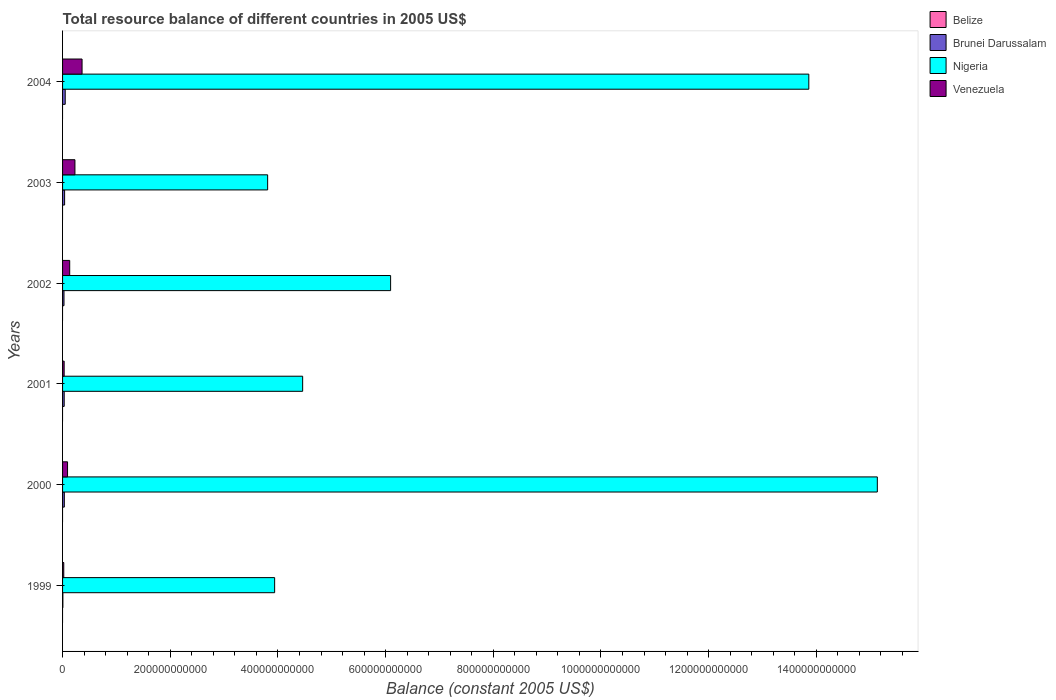How many different coloured bars are there?
Give a very brief answer. 3. How many groups of bars are there?
Offer a very short reply. 6. Are the number of bars per tick equal to the number of legend labels?
Your response must be concise. No. Are the number of bars on each tick of the Y-axis equal?
Offer a terse response. Yes. What is the label of the 3rd group of bars from the top?
Your answer should be compact. 2002. In how many cases, is the number of bars for a given year not equal to the number of legend labels?
Offer a very short reply. 6. What is the total resource balance in Venezuela in 2002?
Your answer should be very brief. 1.33e+1. Across all years, what is the maximum total resource balance in Venezuela?
Provide a short and direct response. 3.62e+1. Across all years, what is the minimum total resource balance in Nigeria?
Keep it short and to the point. 3.81e+11. What is the total total resource balance in Venezuela in the graph?
Your answer should be compact. 8.69e+1. What is the difference between the total resource balance in Nigeria in 2000 and that in 2003?
Your answer should be compact. 1.13e+12. What is the difference between the total resource balance in Brunei Darussalam in 2001 and the total resource balance in Nigeria in 2003?
Provide a short and direct response. -3.78e+11. What is the average total resource balance in Nigeria per year?
Ensure brevity in your answer.  7.88e+11. In the year 1999, what is the difference between the total resource balance in Nigeria and total resource balance in Venezuela?
Your answer should be compact. 3.92e+11. What is the ratio of the total resource balance in Venezuela in 2002 to that in 2003?
Your answer should be compact. 0.58. Is the total resource balance in Nigeria in 2000 less than that in 2001?
Your response must be concise. No. What is the difference between the highest and the second highest total resource balance in Brunei Darussalam?
Provide a succinct answer. 1.12e+09. What is the difference between the highest and the lowest total resource balance in Brunei Darussalam?
Give a very brief answer. 4.35e+09. In how many years, is the total resource balance in Venezuela greater than the average total resource balance in Venezuela taken over all years?
Offer a very short reply. 2. Is it the case that in every year, the sum of the total resource balance in Belize and total resource balance in Brunei Darussalam is greater than the sum of total resource balance in Nigeria and total resource balance in Venezuela?
Give a very brief answer. No. Are all the bars in the graph horizontal?
Provide a short and direct response. Yes. What is the difference between two consecutive major ticks on the X-axis?
Your answer should be very brief. 2.00e+11. Does the graph contain grids?
Your response must be concise. No. How are the legend labels stacked?
Provide a short and direct response. Vertical. What is the title of the graph?
Keep it short and to the point. Total resource balance of different countries in 2005 US$. What is the label or title of the X-axis?
Make the answer very short. Balance (constant 2005 US$). What is the label or title of the Y-axis?
Offer a terse response. Years. What is the Balance (constant 2005 US$) in Brunei Darussalam in 1999?
Provide a succinct answer. 5.78e+08. What is the Balance (constant 2005 US$) in Nigeria in 1999?
Your answer should be very brief. 3.94e+11. What is the Balance (constant 2005 US$) in Venezuela in 1999?
Your answer should be very brief. 2.23e+09. What is the Balance (constant 2005 US$) in Belize in 2000?
Provide a short and direct response. 0. What is the Balance (constant 2005 US$) of Brunei Darussalam in 2000?
Your answer should be compact. 3.26e+09. What is the Balance (constant 2005 US$) in Nigeria in 2000?
Your answer should be compact. 1.51e+12. What is the Balance (constant 2005 US$) in Venezuela in 2000?
Offer a terse response. 9.26e+09. What is the Balance (constant 2005 US$) of Belize in 2001?
Keep it short and to the point. 0. What is the Balance (constant 2005 US$) in Brunei Darussalam in 2001?
Offer a very short reply. 3.04e+09. What is the Balance (constant 2005 US$) of Nigeria in 2001?
Provide a succinct answer. 4.46e+11. What is the Balance (constant 2005 US$) in Venezuela in 2001?
Provide a short and direct response. 2.96e+09. What is the Balance (constant 2005 US$) of Belize in 2002?
Ensure brevity in your answer.  0. What is the Balance (constant 2005 US$) in Brunei Darussalam in 2002?
Provide a short and direct response. 2.67e+09. What is the Balance (constant 2005 US$) in Nigeria in 2002?
Provide a short and direct response. 6.09e+11. What is the Balance (constant 2005 US$) in Venezuela in 2002?
Offer a terse response. 1.33e+1. What is the Balance (constant 2005 US$) of Brunei Darussalam in 2003?
Give a very brief answer. 3.81e+09. What is the Balance (constant 2005 US$) of Nigeria in 2003?
Offer a very short reply. 3.81e+11. What is the Balance (constant 2005 US$) in Venezuela in 2003?
Provide a succinct answer. 2.30e+1. What is the Balance (constant 2005 US$) in Brunei Darussalam in 2004?
Provide a succinct answer. 4.92e+09. What is the Balance (constant 2005 US$) in Nigeria in 2004?
Make the answer very short. 1.39e+12. What is the Balance (constant 2005 US$) in Venezuela in 2004?
Offer a terse response. 3.62e+1. Across all years, what is the maximum Balance (constant 2005 US$) of Brunei Darussalam?
Make the answer very short. 4.92e+09. Across all years, what is the maximum Balance (constant 2005 US$) in Nigeria?
Your answer should be compact. 1.51e+12. Across all years, what is the maximum Balance (constant 2005 US$) in Venezuela?
Provide a succinct answer. 3.62e+1. Across all years, what is the minimum Balance (constant 2005 US$) of Brunei Darussalam?
Offer a terse response. 5.78e+08. Across all years, what is the minimum Balance (constant 2005 US$) of Nigeria?
Keep it short and to the point. 3.81e+11. Across all years, what is the minimum Balance (constant 2005 US$) in Venezuela?
Make the answer very short. 2.23e+09. What is the total Balance (constant 2005 US$) in Brunei Darussalam in the graph?
Provide a succinct answer. 1.83e+1. What is the total Balance (constant 2005 US$) in Nigeria in the graph?
Ensure brevity in your answer.  4.73e+12. What is the total Balance (constant 2005 US$) in Venezuela in the graph?
Your response must be concise. 8.69e+1. What is the difference between the Balance (constant 2005 US$) of Brunei Darussalam in 1999 and that in 2000?
Your answer should be very brief. -2.68e+09. What is the difference between the Balance (constant 2005 US$) of Nigeria in 1999 and that in 2000?
Provide a succinct answer. -1.12e+12. What is the difference between the Balance (constant 2005 US$) in Venezuela in 1999 and that in 2000?
Provide a succinct answer. -7.04e+09. What is the difference between the Balance (constant 2005 US$) in Brunei Darussalam in 1999 and that in 2001?
Your answer should be compact. -2.47e+09. What is the difference between the Balance (constant 2005 US$) of Nigeria in 1999 and that in 2001?
Ensure brevity in your answer.  -5.20e+1. What is the difference between the Balance (constant 2005 US$) of Venezuela in 1999 and that in 2001?
Your response must be concise. -7.35e+08. What is the difference between the Balance (constant 2005 US$) in Brunei Darussalam in 1999 and that in 2002?
Your answer should be compact. -2.09e+09. What is the difference between the Balance (constant 2005 US$) of Nigeria in 1999 and that in 2002?
Give a very brief answer. -2.15e+11. What is the difference between the Balance (constant 2005 US$) of Venezuela in 1999 and that in 2002?
Your answer should be compact. -1.10e+1. What is the difference between the Balance (constant 2005 US$) in Brunei Darussalam in 1999 and that in 2003?
Offer a very short reply. -3.23e+09. What is the difference between the Balance (constant 2005 US$) in Nigeria in 1999 and that in 2003?
Make the answer very short. 1.30e+1. What is the difference between the Balance (constant 2005 US$) of Venezuela in 1999 and that in 2003?
Your response must be concise. -2.08e+1. What is the difference between the Balance (constant 2005 US$) of Brunei Darussalam in 1999 and that in 2004?
Provide a short and direct response. -4.35e+09. What is the difference between the Balance (constant 2005 US$) in Nigeria in 1999 and that in 2004?
Ensure brevity in your answer.  -9.92e+11. What is the difference between the Balance (constant 2005 US$) in Venezuela in 1999 and that in 2004?
Make the answer very short. -3.40e+1. What is the difference between the Balance (constant 2005 US$) of Brunei Darussalam in 2000 and that in 2001?
Your response must be concise. 2.19e+08. What is the difference between the Balance (constant 2005 US$) in Nigeria in 2000 and that in 2001?
Keep it short and to the point. 1.07e+12. What is the difference between the Balance (constant 2005 US$) in Venezuela in 2000 and that in 2001?
Give a very brief answer. 6.30e+09. What is the difference between the Balance (constant 2005 US$) in Brunei Darussalam in 2000 and that in 2002?
Your answer should be very brief. 5.95e+08. What is the difference between the Balance (constant 2005 US$) in Nigeria in 2000 and that in 2002?
Offer a very short reply. 9.04e+11. What is the difference between the Balance (constant 2005 US$) in Venezuela in 2000 and that in 2002?
Ensure brevity in your answer.  -3.99e+09. What is the difference between the Balance (constant 2005 US$) in Brunei Darussalam in 2000 and that in 2003?
Provide a succinct answer. -5.44e+08. What is the difference between the Balance (constant 2005 US$) in Nigeria in 2000 and that in 2003?
Provide a short and direct response. 1.13e+12. What is the difference between the Balance (constant 2005 US$) in Venezuela in 2000 and that in 2003?
Make the answer very short. -1.37e+1. What is the difference between the Balance (constant 2005 US$) of Brunei Darussalam in 2000 and that in 2004?
Provide a succinct answer. -1.66e+09. What is the difference between the Balance (constant 2005 US$) of Nigeria in 2000 and that in 2004?
Keep it short and to the point. 1.27e+11. What is the difference between the Balance (constant 2005 US$) of Venezuela in 2000 and that in 2004?
Your answer should be compact. -2.70e+1. What is the difference between the Balance (constant 2005 US$) of Brunei Darussalam in 2001 and that in 2002?
Keep it short and to the point. 3.76e+08. What is the difference between the Balance (constant 2005 US$) in Nigeria in 2001 and that in 2002?
Your answer should be very brief. -1.63e+11. What is the difference between the Balance (constant 2005 US$) of Venezuela in 2001 and that in 2002?
Ensure brevity in your answer.  -1.03e+1. What is the difference between the Balance (constant 2005 US$) of Brunei Darussalam in 2001 and that in 2003?
Provide a short and direct response. -7.63e+08. What is the difference between the Balance (constant 2005 US$) of Nigeria in 2001 and that in 2003?
Your response must be concise. 6.50e+1. What is the difference between the Balance (constant 2005 US$) in Venezuela in 2001 and that in 2003?
Provide a succinct answer. -2.00e+1. What is the difference between the Balance (constant 2005 US$) of Brunei Darussalam in 2001 and that in 2004?
Keep it short and to the point. -1.88e+09. What is the difference between the Balance (constant 2005 US$) of Nigeria in 2001 and that in 2004?
Make the answer very short. -9.40e+11. What is the difference between the Balance (constant 2005 US$) in Venezuela in 2001 and that in 2004?
Offer a terse response. -3.33e+1. What is the difference between the Balance (constant 2005 US$) in Brunei Darussalam in 2002 and that in 2003?
Offer a very short reply. -1.14e+09. What is the difference between the Balance (constant 2005 US$) of Nigeria in 2002 and that in 2003?
Make the answer very short. 2.28e+11. What is the difference between the Balance (constant 2005 US$) of Venezuela in 2002 and that in 2003?
Provide a succinct answer. -9.74e+09. What is the difference between the Balance (constant 2005 US$) in Brunei Darussalam in 2002 and that in 2004?
Keep it short and to the point. -2.26e+09. What is the difference between the Balance (constant 2005 US$) of Nigeria in 2002 and that in 2004?
Your answer should be compact. -7.77e+11. What is the difference between the Balance (constant 2005 US$) in Venezuela in 2002 and that in 2004?
Offer a terse response. -2.30e+1. What is the difference between the Balance (constant 2005 US$) of Brunei Darussalam in 2003 and that in 2004?
Make the answer very short. -1.12e+09. What is the difference between the Balance (constant 2005 US$) of Nigeria in 2003 and that in 2004?
Ensure brevity in your answer.  -1.01e+12. What is the difference between the Balance (constant 2005 US$) of Venezuela in 2003 and that in 2004?
Your answer should be very brief. -1.32e+1. What is the difference between the Balance (constant 2005 US$) in Brunei Darussalam in 1999 and the Balance (constant 2005 US$) in Nigeria in 2000?
Give a very brief answer. -1.51e+12. What is the difference between the Balance (constant 2005 US$) in Brunei Darussalam in 1999 and the Balance (constant 2005 US$) in Venezuela in 2000?
Offer a terse response. -8.69e+09. What is the difference between the Balance (constant 2005 US$) in Nigeria in 1999 and the Balance (constant 2005 US$) in Venezuela in 2000?
Ensure brevity in your answer.  3.85e+11. What is the difference between the Balance (constant 2005 US$) in Brunei Darussalam in 1999 and the Balance (constant 2005 US$) in Nigeria in 2001?
Offer a terse response. -4.45e+11. What is the difference between the Balance (constant 2005 US$) in Brunei Darussalam in 1999 and the Balance (constant 2005 US$) in Venezuela in 2001?
Offer a terse response. -2.38e+09. What is the difference between the Balance (constant 2005 US$) in Nigeria in 1999 and the Balance (constant 2005 US$) in Venezuela in 2001?
Your response must be concise. 3.91e+11. What is the difference between the Balance (constant 2005 US$) in Brunei Darussalam in 1999 and the Balance (constant 2005 US$) in Nigeria in 2002?
Give a very brief answer. -6.09e+11. What is the difference between the Balance (constant 2005 US$) in Brunei Darussalam in 1999 and the Balance (constant 2005 US$) in Venezuela in 2002?
Keep it short and to the point. -1.27e+1. What is the difference between the Balance (constant 2005 US$) of Nigeria in 1999 and the Balance (constant 2005 US$) of Venezuela in 2002?
Offer a terse response. 3.81e+11. What is the difference between the Balance (constant 2005 US$) of Brunei Darussalam in 1999 and the Balance (constant 2005 US$) of Nigeria in 2003?
Your answer should be compact. -3.80e+11. What is the difference between the Balance (constant 2005 US$) in Brunei Darussalam in 1999 and the Balance (constant 2005 US$) in Venezuela in 2003?
Keep it short and to the point. -2.24e+1. What is the difference between the Balance (constant 2005 US$) in Nigeria in 1999 and the Balance (constant 2005 US$) in Venezuela in 2003?
Make the answer very short. 3.71e+11. What is the difference between the Balance (constant 2005 US$) in Brunei Darussalam in 1999 and the Balance (constant 2005 US$) in Nigeria in 2004?
Give a very brief answer. -1.39e+12. What is the difference between the Balance (constant 2005 US$) of Brunei Darussalam in 1999 and the Balance (constant 2005 US$) of Venezuela in 2004?
Ensure brevity in your answer.  -3.56e+1. What is the difference between the Balance (constant 2005 US$) in Nigeria in 1999 and the Balance (constant 2005 US$) in Venezuela in 2004?
Your answer should be very brief. 3.58e+11. What is the difference between the Balance (constant 2005 US$) of Brunei Darussalam in 2000 and the Balance (constant 2005 US$) of Nigeria in 2001?
Provide a succinct answer. -4.43e+11. What is the difference between the Balance (constant 2005 US$) in Brunei Darussalam in 2000 and the Balance (constant 2005 US$) in Venezuela in 2001?
Offer a terse response. 3.01e+08. What is the difference between the Balance (constant 2005 US$) in Nigeria in 2000 and the Balance (constant 2005 US$) in Venezuela in 2001?
Your response must be concise. 1.51e+12. What is the difference between the Balance (constant 2005 US$) in Brunei Darussalam in 2000 and the Balance (constant 2005 US$) in Nigeria in 2002?
Provide a succinct answer. -6.06e+11. What is the difference between the Balance (constant 2005 US$) of Brunei Darussalam in 2000 and the Balance (constant 2005 US$) of Venezuela in 2002?
Offer a terse response. -9.99e+09. What is the difference between the Balance (constant 2005 US$) in Nigeria in 2000 and the Balance (constant 2005 US$) in Venezuela in 2002?
Ensure brevity in your answer.  1.50e+12. What is the difference between the Balance (constant 2005 US$) of Brunei Darussalam in 2000 and the Balance (constant 2005 US$) of Nigeria in 2003?
Keep it short and to the point. -3.78e+11. What is the difference between the Balance (constant 2005 US$) in Brunei Darussalam in 2000 and the Balance (constant 2005 US$) in Venezuela in 2003?
Ensure brevity in your answer.  -1.97e+1. What is the difference between the Balance (constant 2005 US$) of Nigeria in 2000 and the Balance (constant 2005 US$) of Venezuela in 2003?
Provide a short and direct response. 1.49e+12. What is the difference between the Balance (constant 2005 US$) of Brunei Darussalam in 2000 and the Balance (constant 2005 US$) of Nigeria in 2004?
Provide a short and direct response. -1.38e+12. What is the difference between the Balance (constant 2005 US$) of Brunei Darussalam in 2000 and the Balance (constant 2005 US$) of Venezuela in 2004?
Your response must be concise. -3.30e+1. What is the difference between the Balance (constant 2005 US$) in Nigeria in 2000 and the Balance (constant 2005 US$) in Venezuela in 2004?
Provide a short and direct response. 1.48e+12. What is the difference between the Balance (constant 2005 US$) in Brunei Darussalam in 2001 and the Balance (constant 2005 US$) in Nigeria in 2002?
Offer a very short reply. -6.06e+11. What is the difference between the Balance (constant 2005 US$) in Brunei Darussalam in 2001 and the Balance (constant 2005 US$) in Venezuela in 2002?
Offer a very short reply. -1.02e+1. What is the difference between the Balance (constant 2005 US$) in Nigeria in 2001 and the Balance (constant 2005 US$) in Venezuela in 2002?
Provide a succinct answer. 4.33e+11. What is the difference between the Balance (constant 2005 US$) of Brunei Darussalam in 2001 and the Balance (constant 2005 US$) of Nigeria in 2003?
Provide a short and direct response. -3.78e+11. What is the difference between the Balance (constant 2005 US$) in Brunei Darussalam in 2001 and the Balance (constant 2005 US$) in Venezuela in 2003?
Make the answer very short. -1.99e+1. What is the difference between the Balance (constant 2005 US$) of Nigeria in 2001 and the Balance (constant 2005 US$) of Venezuela in 2003?
Ensure brevity in your answer.  4.23e+11. What is the difference between the Balance (constant 2005 US$) in Brunei Darussalam in 2001 and the Balance (constant 2005 US$) in Nigeria in 2004?
Your answer should be compact. -1.38e+12. What is the difference between the Balance (constant 2005 US$) of Brunei Darussalam in 2001 and the Balance (constant 2005 US$) of Venezuela in 2004?
Ensure brevity in your answer.  -3.32e+1. What is the difference between the Balance (constant 2005 US$) in Nigeria in 2001 and the Balance (constant 2005 US$) in Venezuela in 2004?
Your answer should be compact. 4.10e+11. What is the difference between the Balance (constant 2005 US$) of Brunei Darussalam in 2002 and the Balance (constant 2005 US$) of Nigeria in 2003?
Give a very brief answer. -3.78e+11. What is the difference between the Balance (constant 2005 US$) of Brunei Darussalam in 2002 and the Balance (constant 2005 US$) of Venezuela in 2003?
Your response must be concise. -2.03e+1. What is the difference between the Balance (constant 2005 US$) of Nigeria in 2002 and the Balance (constant 2005 US$) of Venezuela in 2003?
Offer a terse response. 5.86e+11. What is the difference between the Balance (constant 2005 US$) in Brunei Darussalam in 2002 and the Balance (constant 2005 US$) in Nigeria in 2004?
Offer a terse response. -1.38e+12. What is the difference between the Balance (constant 2005 US$) of Brunei Darussalam in 2002 and the Balance (constant 2005 US$) of Venezuela in 2004?
Your response must be concise. -3.36e+1. What is the difference between the Balance (constant 2005 US$) of Nigeria in 2002 and the Balance (constant 2005 US$) of Venezuela in 2004?
Your answer should be compact. 5.73e+11. What is the difference between the Balance (constant 2005 US$) in Brunei Darussalam in 2003 and the Balance (constant 2005 US$) in Nigeria in 2004?
Offer a very short reply. -1.38e+12. What is the difference between the Balance (constant 2005 US$) of Brunei Darussalam in 2003 and the Balance (constant 2005 US$) of Venezuela in 2004?
Provide a short and direct response. -3.24e+1. What is the difference between the Balance (constant 2005 US$) of Nigeria in 2003 and the Balance (constant 2005 US$) of Venezuela in 2004?
Ensure brevity in your answer.  3.45e+11. What is the average Balance (constant 2005 US$) in Brunei Darussalam per year?
Your answer should be very brief. 3.05e+09. What is the average Balance (constant 2005 US$) of Nigeria per year?
Your answer should be very brief. 7.88e+11. What is the average Balance (constant 2005 US$) in Venezuela per year?
Give a very brief answer. 1.45e+1. In the year 1999, what is the difference between the Balance (constant 2005 US$) in Brunei Darussalam and Balance (constant 2005 US$) in Nigeria?
Make the answer very short. -3.93e+11. In the year 1999, what is the difference between the Balance (constant 2005 US$) in Brunei Darussalam and Balance (constant 2005 US$) in Venezuela?
Provide a short and direct response. -1.65e+09. In the year 1999, what is the difference between the Balance (constant 2005 US$) of Nigeria and Balance (constant 2005 US$) of Venezuela?
Give a very brief answer. 3.92e+11. In the year 2000, what is the difference between the Balance (constant 2005 US$) of Brunei Darussalam and Balance (constant 2005 US$) of Nigeria?
Offer a very short reply. -1.51e+12. In the year 2000, what is the difference between the Balance (constant 2005 US$) of Brunei Darussalam and Balance (constant 2005 US$) of Venezuela?
Offer a terse response. -6.00e+09. In the year 2000, what is the difference between the Balance (constant 2005 US$) in Nigeria and Balance (constant 2005 US$) in Venezuela?
Keep it short and to the point. 1.50e+12. In the year 2001, what is the difference between the Balance (constant 2005 US$) of Brunei Darussalam and Balance (constant 2005 US$) of Nigeria?
Offer a terse response. -4.43e+11. In the year 2001, what is the difference between the Balance (constant 2005 US$) in Brunei Darussalam and Balance (constant 2005 US$) in Venezuela?
Offer a terse response. 8.20e+07. In the year 2001, what is the difference between the Balance (constant 2005 US$) of Nigeria and Balance (constant 2005 US$) of Venezuela?
Provide a succinct answer. 4.43e+11. In the year 2002, what is the difference between the Balance (constant 2005 US$) in Brunei Darussalam and Balance (constant 2005 US$) in Nigeria?
Give a very brief answer. -6.07e+11. In the year 2002, what is the difference between the Balance (constant 2005 US$) in Brunei Darussalam and Balance (constant 2005 US$) in Venezuela?
Make the answer very short. -1.06e+1. In the year 2002, what is the difference between the Balance (constant 2005 US$) in Nigeria and Balance (constant 2005 US$) in Venezuela?
Your answer should be very brief. 5.96e+11. In the year 2003, what is the difference between the Balance (constant 2005 US$) of Brunei Darussalam and Balance (constant 2005 US$) of Nigeria?
Give a very brief answer. -3.77e+11. In the year 2003, what is the difference between the Balance (constant 2005 US$) in Brunei Darussalam and Balance (constant 2005 US$) in Venezuela?
Offer a terse response. -1.92e+1. In the year 2003, what is the difference between the Balance (constant 2005 US$) in Nigeria and Balance (constant 2005 US$) in Venezuela?
Offer a very short reply. 3.58e+11. In the year 2004, what is the difference between the Balance (constant 2005 US$) in Brunei Darussalam and Balance (constant 2005 US$) in Nigeria?
Offer a very short reply. -1.38e+12. In the year 2004, what is the difference between the Balance (constant 2005 US$) in Brunei Darussalam and Balance (constant 2005 US$) in Venezuela?
Provide a succinct answer. -3.13e+1. In the year 2004, what is the difference between the Balance (constant 2005 US$) of Nigeria and Balance (constant 2005 US$) of Venezuela?
Offer a terse response. 1.35e+12. What is the ratio of the Balance (constant 2005 US$) in Brunei Darussalam in 1999 to that in 2000?
Provide a succinct answer. 0.18. What is the ratio of the Balance (constant 2005 US$) in Nigeria in 1999 to that in 2000?
Offer a terse response. 0.26. What is the ratio of the Balance (constant 2005 US$) in Venezuela in 1999 to that in 2000?
Your response must be concise. 0.24. What is the ratio of the Balance (constant 2005 US$) in Brunei Darussalam in 1999 to that in 2001?
Make the answer very short. 0.19. What is the ratio of the Balance (constant 2005 US$) in Nigeria in 1999 to that in 2001?
Your answer should be very brief. 0.88. What is the ratio of the Balance (constant 2005 US$) in Venezuela in 1999 to that in 2001?
Your response must be concise. 0.75. What is the ratio of the Balance (constant 2005 US$) of Brunei Darussalam in 1999 to that in 2002?
Your answer should be very brief. 0.22. What is the ratio of the Balance (constant 2005 US$) in Nigeria in 1999 to that in 2002?
Give a very brief answer. 0.65. What is the ratio of the Balance (constant 2005 US$) in Venezuela in 1999 to that in 2002?
Offer a terse response. 0.17. What is the ratio of the Balance (constant 2005 US$) of Brunei Darussalam in 1999 to that in 2003?
Your response must be concise. 0.15. What is the ratio of the Balance (constant 2005 US$) in Nigeria in 1999 to that in 2003?
Give a very brief answer. 1.03. What is the ratio of the Balance (constant 2005 US$) in Venezuela in 1999 to that in 2003?
Your answer should be compact. 0.1. What is the ratio of the Balance (constant 2005 US$) of Brunei Darussalam in 1999 to that in 2004?
Give a very brief answer. 0.12. What is the ratio of the Balance (constant 2005 US$) of Nigeria in 1999 to that in 2004?
Your answer should be very brief. 0.28. What is the ratio of the Balance (constant 2005 US$) of Venezuela in 1999 to that in 2004?
Offer a very short reply. 0.06. What is the ratio of the Balance (constant 2005 US$) in Brunei Darussalam in 2000 to that in 2001?
Offer a terse response. 1.07. What is the ratio of the Balance (constant 2005 US$) of Nigeria in 2000 to that in 2001?
Provide a short and direct response. 3.39. What is the ratio of the Balance (constant 2005 US$) in Venezuela in 2000 to that in 2001?
Ensure brevity in your answer.  3.13. What is the ratio of the Balance (constant 2005 US$) of Brunei Darussalam in 2000 to that in 2002?
Provide a succinct answer. 1.22. What is the ratio of the Balance (constant 2005 US$) in Nigeria in 2000 to that in 2002?
Ensure brevity in your answer.  2.48. What is the ratio of the Balance (constant 2005 US$) in Venezuela in 2000 to that in 2002?
Offer a very short reply. 0.7. What is the ratio of the Balance (constant 2005 US$) in Brunei Darussalam in 2000 to that in 2003?
Your response must be concise. 0.86. What is the ratio of the Balance (constant 2005 US$) of Nigeria in 2000 to that in 2003?
Provide a succinct answer. 3.97. What is the ratio of the Balance (constant 2005 US$) of Venezuela in 2000 to that in 2003?
Your answer should be very brief. 0.4. What is the ratio of the Balance (constant 2005 US$) in Brunei Darussalam in 2000 to that in 2004?
Your response must be concise. 0.66. What is the ratio of the Balance (constant 2005 US$) of Nigeria in 2000 to that in 2004?
Provide a short and direct response. 1.09. What is the ratio of the Balance (constant 2005 US$) in Venezuela in 2000 to that in 2004?
Your answer should be compact. 0.26. What is the ratio of the Balance (constant 2005 US$) of Brunei Darussalam in 2001 to that in 2002?
Make the answer very short. 1.14. What is the ratio of the Balance (constant 2005 US$) in Nigeria in 2001 to that in 2002?
Give a very brief answer. 0.73. What is the ratio of the Balance (constant 2005 US$) in Venezuela in 2001 to that in 2002?
Provide a succinct answer. 0.22. What is the ratio of the Balance (constant 2005 US$) of Brunei Darussalam in 2001 to that in 2003?
Ensure brevity in your answer.  0.8. What is the ratio of the Balance (constant 2005 US$) of Nigeria in 2001 to that in 2003?
Ensure brevity in your answer.  1.17. What is the ratio of the Balance (constant 2005 US$) in Venezuela in 2001 to that in 2003?
Your answer should be compact. 0.13. What is the ratio of the Balance (constant 2005 US$) of Brunei Darussalam in 2001 to that in 2004?
Your answer should be compact. 0.62. What is the ratio of the Balance (constant 2005 US$) in Nigeria in 2001 to that in 2004?
Provide a succinct answer. 0.32. What is the ratio of the Balance (constant 2005 US$) of Venezuela in 2001 to that in 2004?
Your answer should be compact. 0.08. What is the ratio of the Balance (constant 2005 US$) in Brunei Darussalam in 2002 to that in 2003?
Provide a short and direct response. 0.7. What is the ratio of the Balance (constant 2005 US$) in Nigeria in 2002 to that in 2003?
Make the answer very short. 1.6. What is the ratio of the Balance (constant 2005 US$) of Venezuela in 2002 to that in 2003?
Make the answer very short. 0.58. What is the ratio of the Balance (constant 2005 US$) in Brunei Darussalam in 2002 to that in 2004?
Your answer should be very brief. 0.54. What is the ratio of the Balance (constant 2005 US$) of Nigeria in 2002 to that in 2004?
Provide a short and direct response. 0.44. What is the ratio of the Balance (constant 2005 US$) of Venezuela in 2002 to that in 2004?
Offer a very short reply. 0.37. What is the ratio of the Balance (constant 2005 US$) of Brunei Darussalam in 2003 to that in 2004?
Your answer should be very brief. 0.77. What is the ratio of the Balance (constant 2005 US$) of Nigeria in 2003 to that in 2004?
Your response must be concise. 0.27. What is the ratio of the Balance (constant 2005 US$) of Venezuela in 2003 to that in 2004?
Offer a very short reply. 0.63. What is the difference between the highest and the second highest Balance (constant 2005 US$) of Brunei Darussalam?
Ensure brevity in your answer.  1.12e+09. What is the difference between the highest and the second highest Balance (constant 2005 US$) of Nigeria?
Keep it short and to the point. 1.27e+11. What is the difference between the highest and the second highest Balance (constant 2005 US$) in Venezuela?
Make the answer very short. 1.32e+1. What is the difference between the highest and the lowest Balance (constant 2005 US$) of Brunei Darussalam?
Keep it short and to the point. 4.35e+09. What is the difference between the highest and the lowest Balance (constant 2005 US$) of Nigeria?
Provide a succinct answer. 1.13e+12. What is the difference between the highest and the lowest Balance (constant 2005 US$) of Venezuela?
Your response must be concise. 3.40e+1. 